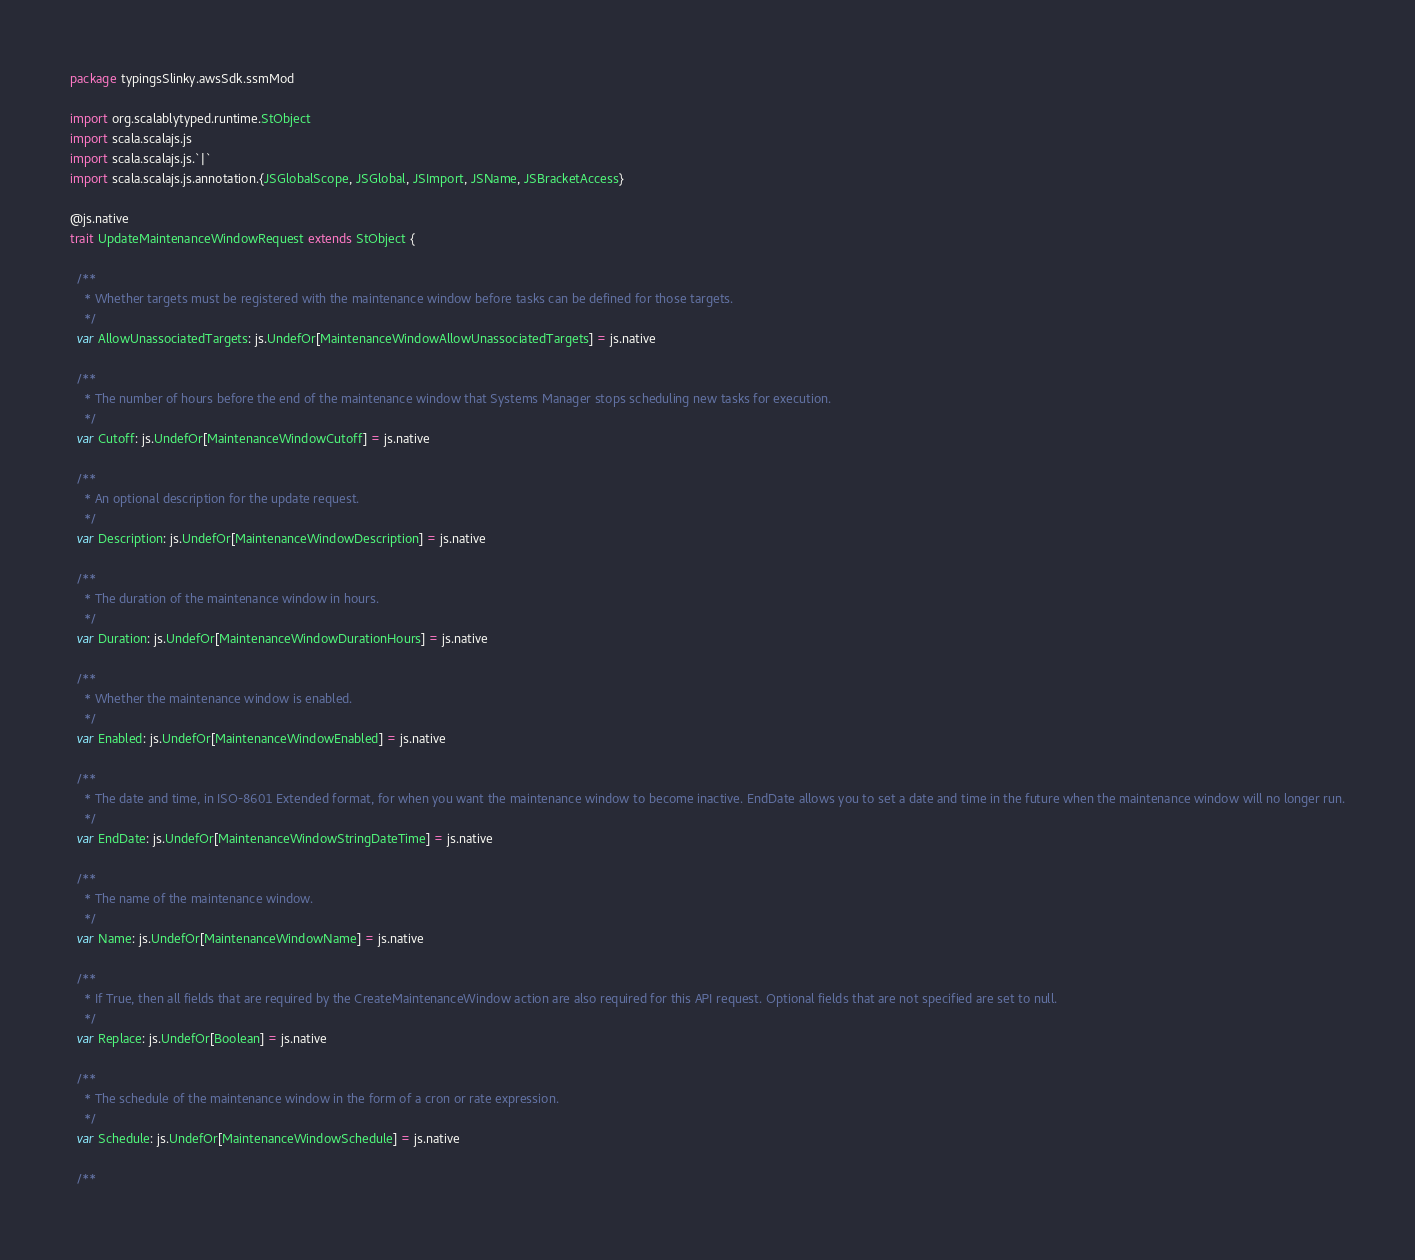<code> <loc_0><loc_0><loc_500><loc_500><_Scala_>package typingsSlinky.awsSdk.ssmMod

import org.scalablytyped.runtime.StObject
import scala.scalajs.js
import scala.scalajs.js.`|`
import scala.scalajs.js.annotation.{JSGlobalScope, JSGlobal, JSImport, JSName, JSBracketAccess}

@js.native
trait UpdateMaintenanceWindowRequest extends StObject {
  
  /**
    * Whether targets must be registered with the maintenance window before tasks can be defined for those targets.
    */
  var AllowUnassociatedTargets: js.UndefOr[MaintenanceWindowAllowUnassociatedTargets] = js.native
  
  /**
    * The number of hours before the end of the maintenance window that Systems Manager stops scheduling new tasks for execution.
    */
  var Cutoff: js.UndefOr[MaintenanceWindowCutoff] = js.native
  
  /**
    * An optional description for the update request.
    */
  var Description: js.UndefOr[MaintenanceWindowDescription] = js.native
  
  /**
    * The duration of the maintenance window in hours.
    */
  var Duration: js.UndefOr[MaintenanceWindowDurationHours] = js.native
  
  /**
    * Whether the maintenance window is enabled.
    */
  var Enabled: js.UndefOr[MaintenanceWindowEnabled] = js.native
  
  /**
    * The date and time, in ISO-8601 Extended format, for when you want the maintenance window to become inactive. EndDate allows you to set a date and time in the future when the maintenance window will no longer run.
    */
  var EndDate: js.UndefOr[MaintenanceWindowStringDateTime] = js.native
  
  /**
    * The name of the maintenance window.
    */
  var Name: js.UndefOr[MaintenanceWindowName] = js.native
  
  /**
    * If True, then all fields that are required by the CreateMaintenanceWindow action are also required for this API request. Optional fields that are not specified are set to null. 
    */
  var Replace: js.UndefOr[Boolean] = js.native
  
  /**
    * The schedule of the maintenance window in the form of a cron or rate expression.
    */
  var Schedule: js.UndefOr[MaintenanceWindowSchedule] = js.native
  
  /**</code> 